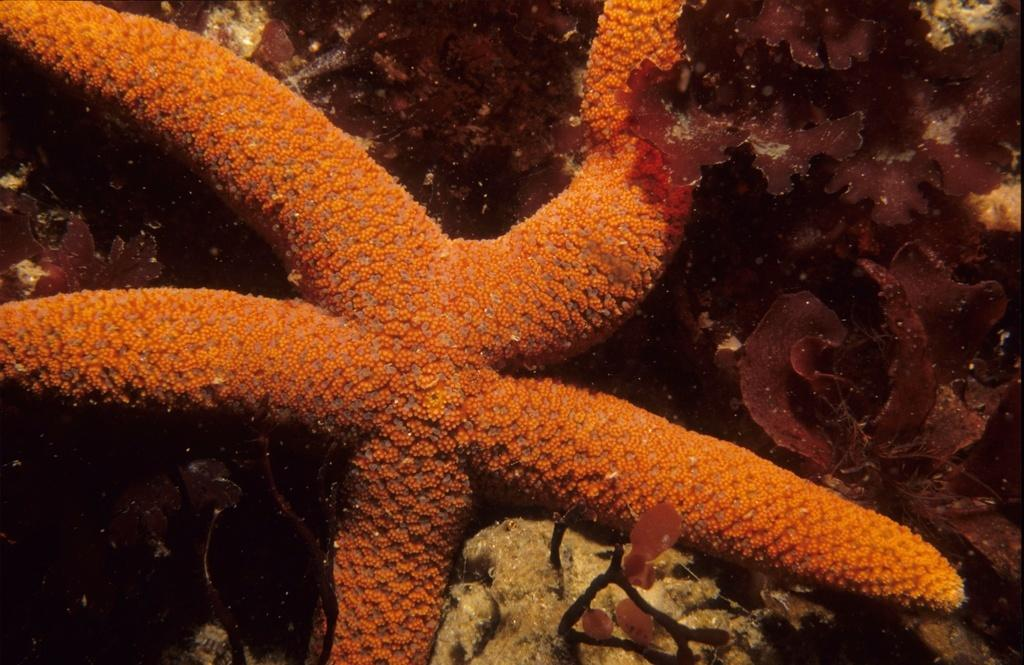What type of marine animal is in the image? There is a starfish in the image. What type of weather can be seen in the image? There is no weather visible in the image, as it features a starfish and does not depict any outdoor environment. 